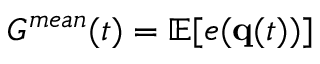<formula> <loc_0><loc_0><loc_500><loc_500>G ^ { m e a n } ( t ) = \mathbb { E } [ e ( { q } ( t ) ) ]</formula> 